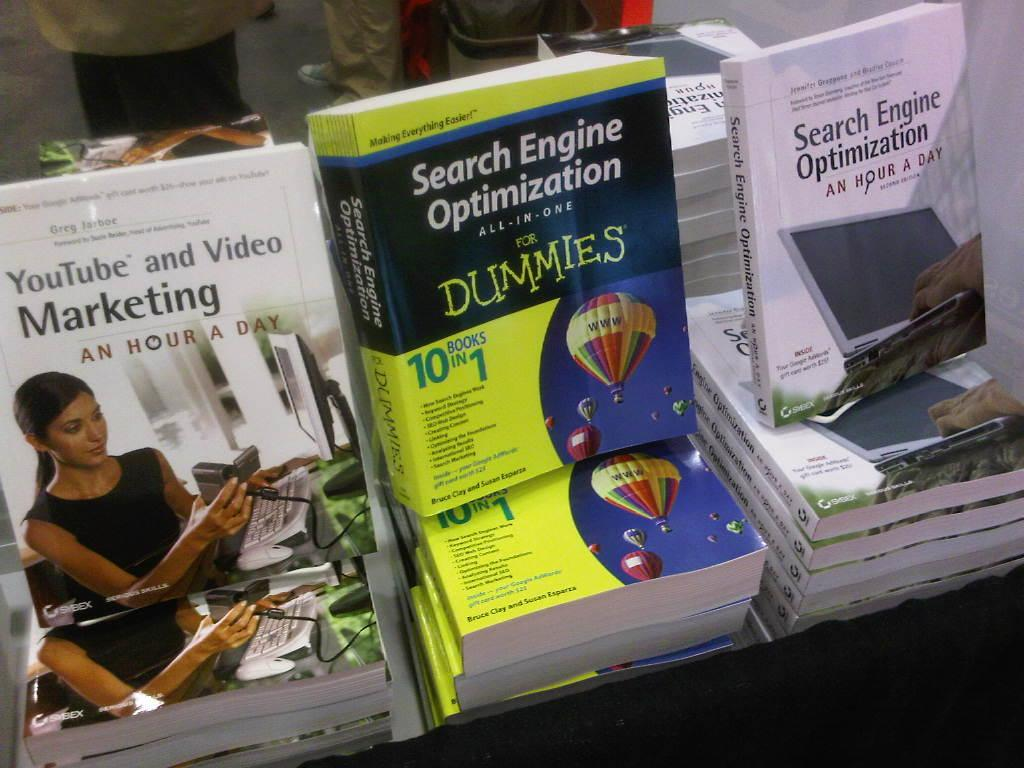<image>
Summarize the visual content of the image. Three books sit next to each other dealing with Search Engine Optimization. 